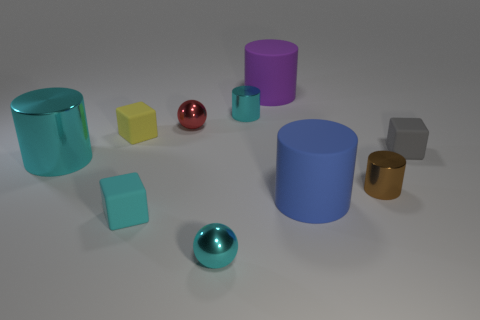Subtract all tiny brown cylinders. How many cylinders are left? 4 Subtract 2 cubes. How many cubes are left? 1 Subtract all cubes. How many objects are left? 7 Subtract all red balls. How many balls are left? 1 Subtract all red spheres. How many cyan cylinders are left? 2 Subtract all rubber things. Subtract all matte cubes. How many objects are left? 2 Add 2 small metallic spheres. How many small metallic spheres are left? 4 Add 3 tiny yellow matte objects. How many tiny yellow matte objects exist? 4 Subtract 0 brown blocks. How many objects are left? 10 Subtract all green cubes. Subtract all gray balls. How many cubes are left? 3 